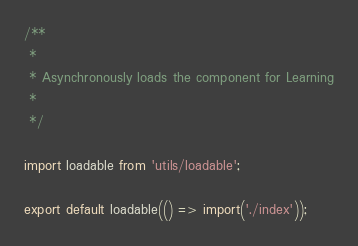<code> <loc_0><loc_0><loc_500><loc_500><_JavaScript_>/**
 *
 * Asynchronously loads the component for Learning
 *
 */

import loadable from 'utils/loadable';

export default loadable(() => import('./index'));
</code> 